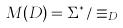Convert formula to latex. <formula><loc_0><loc_0><loc_500><loc_500>M ( D ) = \Sigma ^ { * } / \equiv _ { D }</formula> 